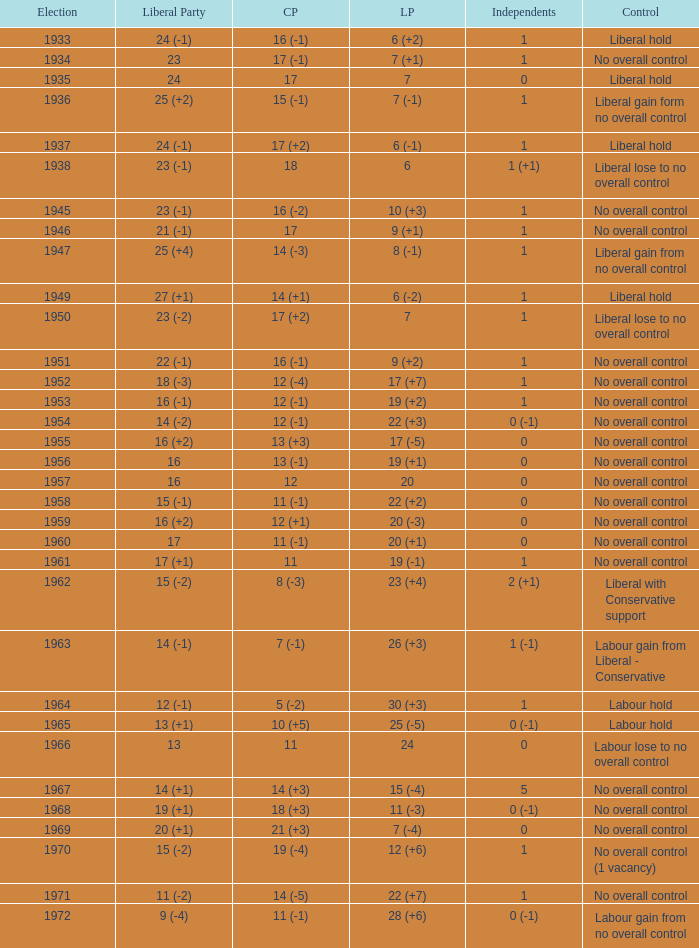What was the control for the year with a Conservative Party result of 10 (+5)? Labour hold. 